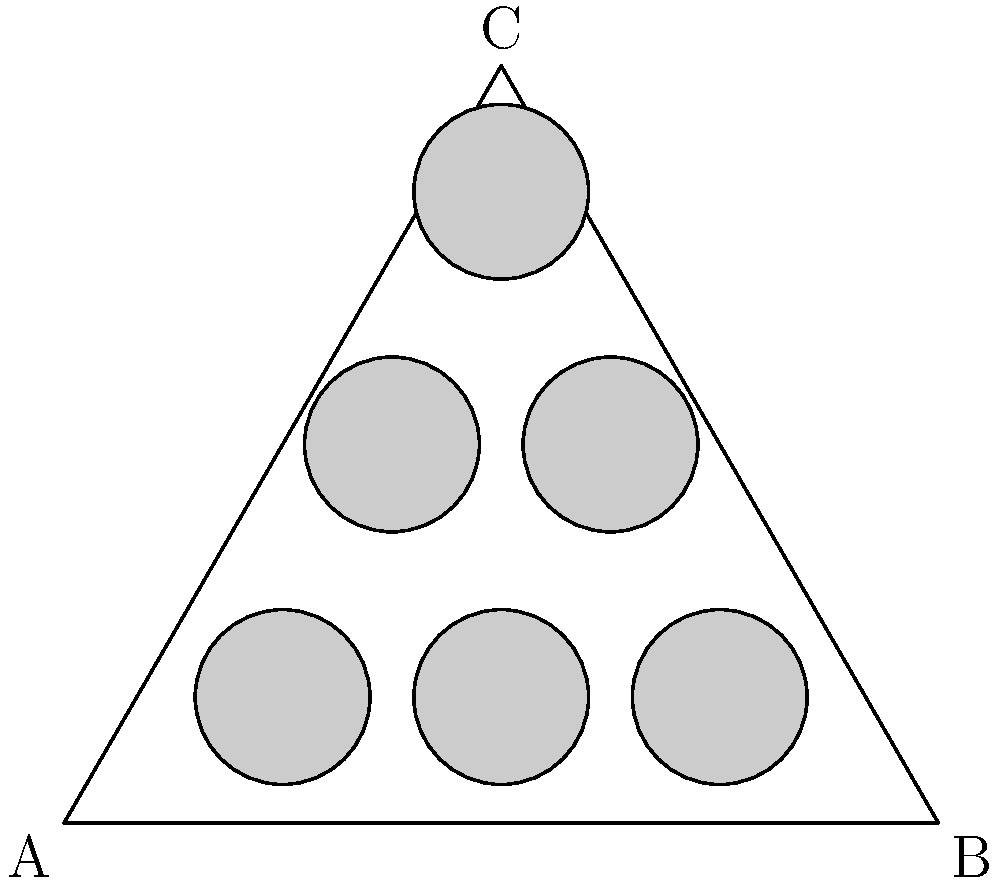You've got a fancy triangular shelf for your top-shelf liquor. The shelf is an equilateral triangle with side length 10 units. You want to arrange circular bottles (diameter 2 units) in a triangular pattern to maximize space usage. How many bottles can you fit without any overlap? Let's approach this step-by-step:

1) First, we need to understand the geometry of an equilateral triangle:
   - Side length = 10 units
   - Height (h) = $\frac{\sqrt{3}}{2} \times 10 = 5\sqrt{3} \approx 8.66$ units

2) The bottles are circular with diameter 2 units, so radius = 1 unit.

3) To maximize space, we'll arrange the bottles in a triangular pattern:
   - Bottom row: 3 bottles
   - Middle row: 2 bottles
   - Top row: 1 bottle

4) Let's check if this arrangement fits:
   - Bottom row: 
     * Width needed = 4 units (2 diameters + 1 radius on each side)
     * Available width = 10 units
     * 4 < 10, so it fits

   - Middle row:
     * Width needed = 3 units (1.5 diameters + 0.75 radius on each side)
     * Available width at this height ≈ 7.5 units
     * 3 < 7.5, so it fits

   - Top row:
     * Only one bottle, clearly fits

5) Vertical spacing:
   - Distance between rows = $\frac{\sqrt{3}}{2} \times 2 = \sqrt{3} \approx 1.73$ units
   - Height needed = $2 + 2\sqrt{3} \approx 5.46$ units
   - Available height = $5\sqrt{3} \approx 8.66$ units
   - 5.46 < 8.66, so it fits vertically

Therefore, this arrangement of 6 bottles (3+2+1) fits without overlap.
Answer: 6 bottles 